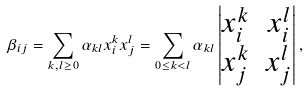<formula> <loc_0><loc_0><loc_500><loc_500>\beta _ { i j } = \sum _ { k , l \geq 0 } \alpha _ { k l } x _ { i } ^ { k } x _ { j } ^ { l } = \sum _ { 0 \leq k < l } \alpha _ { k l } \begin{vmatrix} x _ { i } ^ { k } & x _ { i } ^ { l } \\ x _ { j } ^ { k } & x _ { j } ^ { l } \end{vmatrix} ,</formula> 